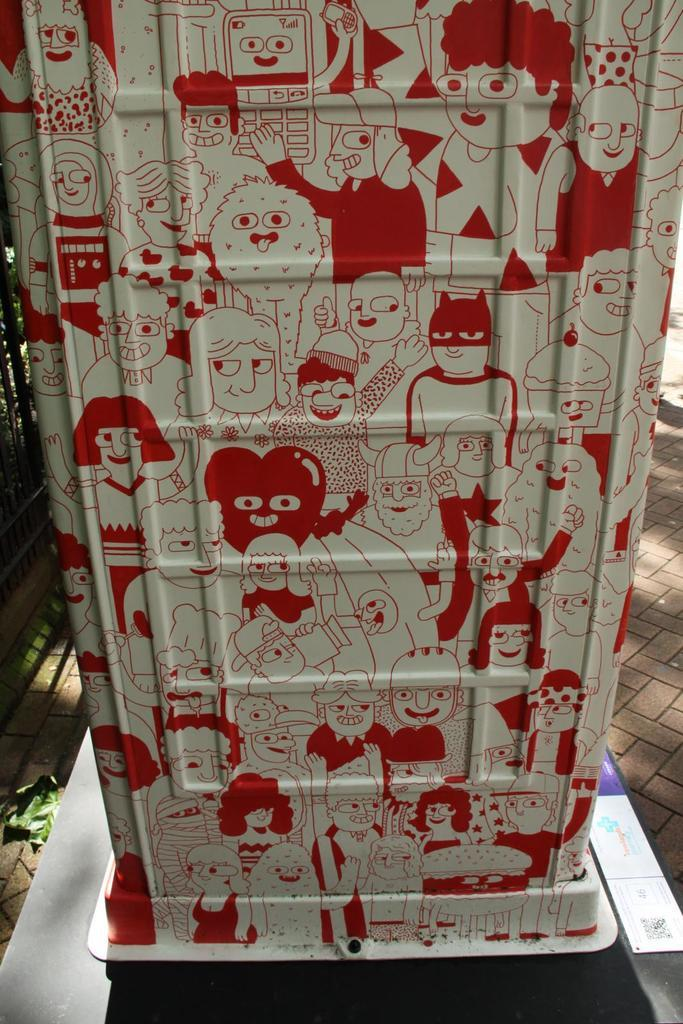What is the main object in the image? There is a box in the image. What can be seen on the surface of the box? The box has pictures on it. Where is the box located in the image? The box is on a platform. What other object can be seen in the image? There is a board in the image. What type of drain can be seen on the box in the image? There is no drain present on the box in the image. What color is the wren sitting on the board in the image? There is no wren present in the image. 